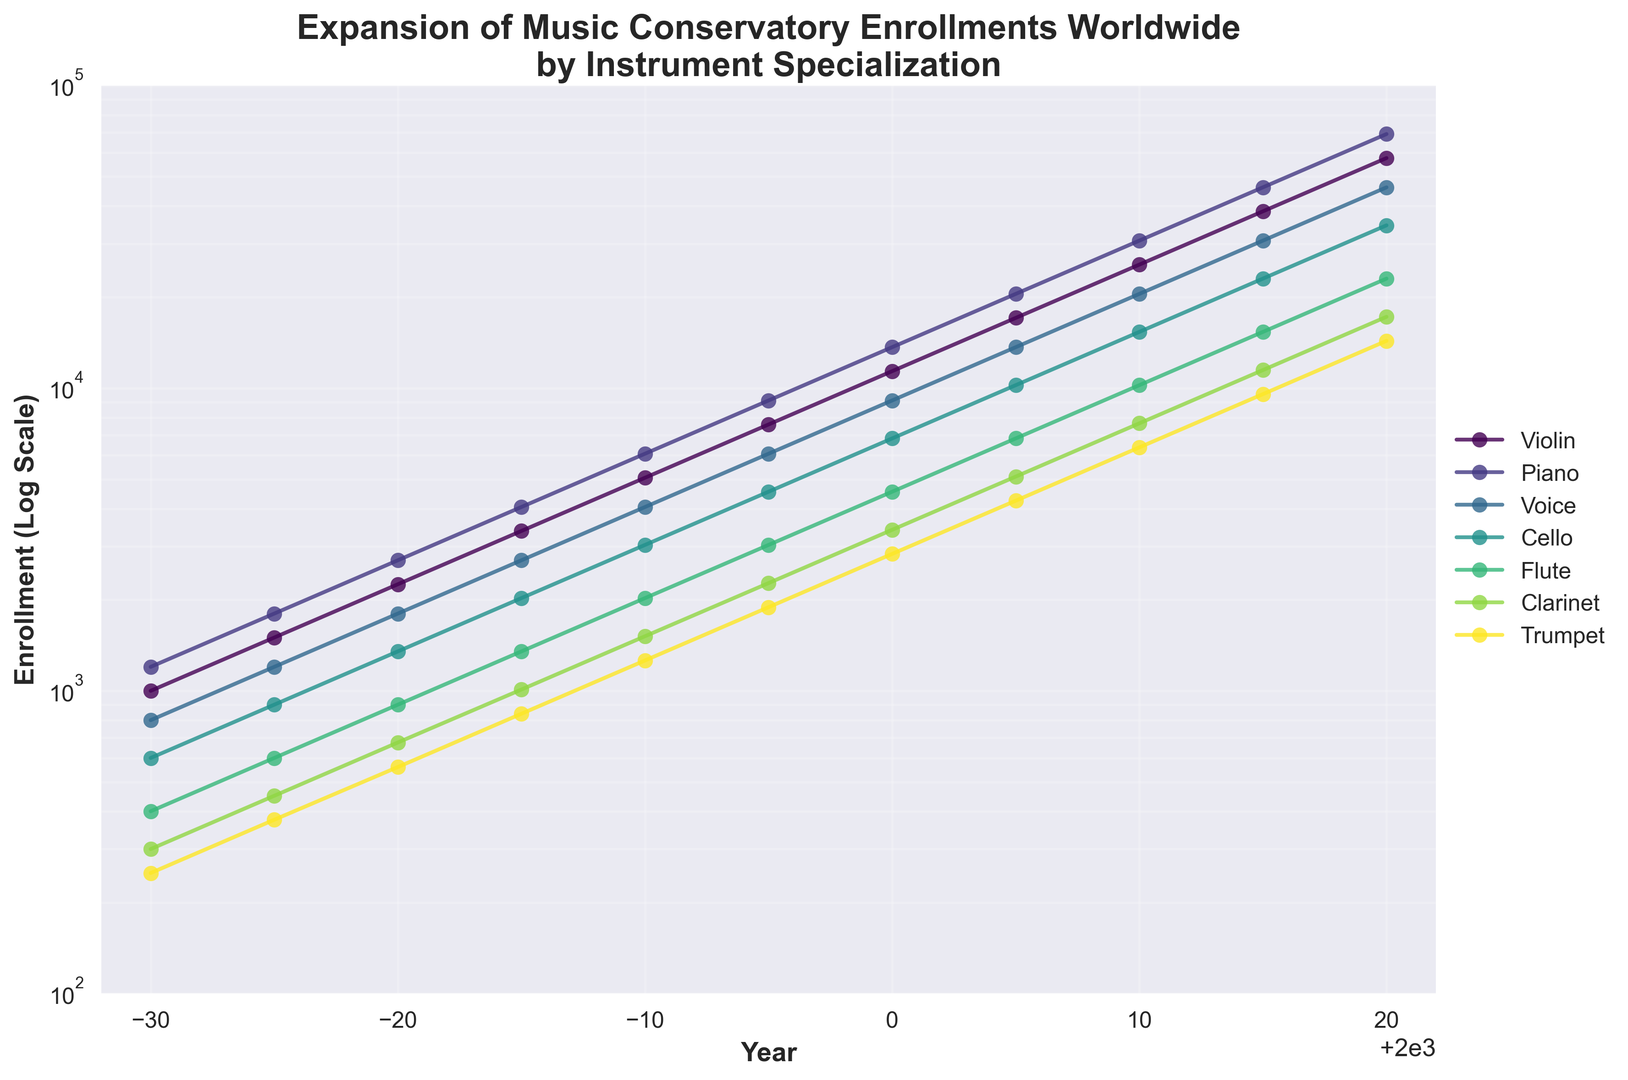What is the enrollment trend for violin from 1970 to 2020? From the figure, observe the line corresponding to violin throughout the years. The line shows a consistent upward trend, following an exponential growth pattern as it increases steadily from 1970 to 2020.
Answer: Upward trend Which instrument had the highest enrollment in 1995? Check the enrollment values at the year 1995 for each instrument in the figure. The instrument with the highest marker and highest value on the y-axis is Piano.
Answer: Piano How does the 2020 enrollment for cello compare to that of flute in 2000? Find and compare the markers for cello in 2020 and flute in 2000. Cello in 2020 is higher on the log scale, indicating a larger enrollment than flute in 2000.
Answer: Cello in 2020 is higher What is the difference in enrollment between voice and trumpet in 2010? Locate the values for voice and trumpet in 2010 from the figure. Voice (20495) minus Trumpet (6375) results in a difference of 14120.
Answer: 14120 Which instrument showed the fastest growth in enrollment from 1970 to 1980? Compare the slopes of the lines for each instrument between 1970 and 1980. The instrument with the steepest slope will indicate the fastest growth. Violin shows the steepest increase relative to its starting point.
Answer: Violin Calculate the average enrollment of piano from 1970 to 2020. Sum the enrollment values for piano across all years (1200 + 1800 + 2700 + 4050 + 6075 + 9110 + 13665 + 20495 + 30740 + 46110 + 69165) and divide by the number of years (11). The total sum is 206110, the average is 206110 / 11 = 18737.
Answer: 18737 Which instrument had the smallest increase in enrollment from 2000 to 2020? Identify the change in values for each instrument from 2000 to 2020 and find the instrument with the smallest difference. Trumpet increased from 2835 to 14340, the smallest among all instruments.
Answer: Trumpet By what factor did flute enrollment increase from 1980 to 2010? Calculate the factor by dividing the 2010 enrollment by the 1980 enrollment for flute (10235 / 900). The result is approximately 11.37.
Answer: Approximately 11.37 In which year did trumpet and flute have equal enrollments or nearest to equal? Look for overlaps or points where the lines for trumpet and flute markers are closest. In 1975, trumpet and flute enrollments are quite close, 375 and 450 respectively.
Answer: 1975 What is the median enrollment for clarinet over the years in the figure? List the clarinet enrollments in order and find the median (middle value) as the 6th value in the sorted list (300, 450, 675, 1010, 1515, 2270, 3405, 5105, 7655, 11480, 17220), which is 2270.
Answer: 2270 